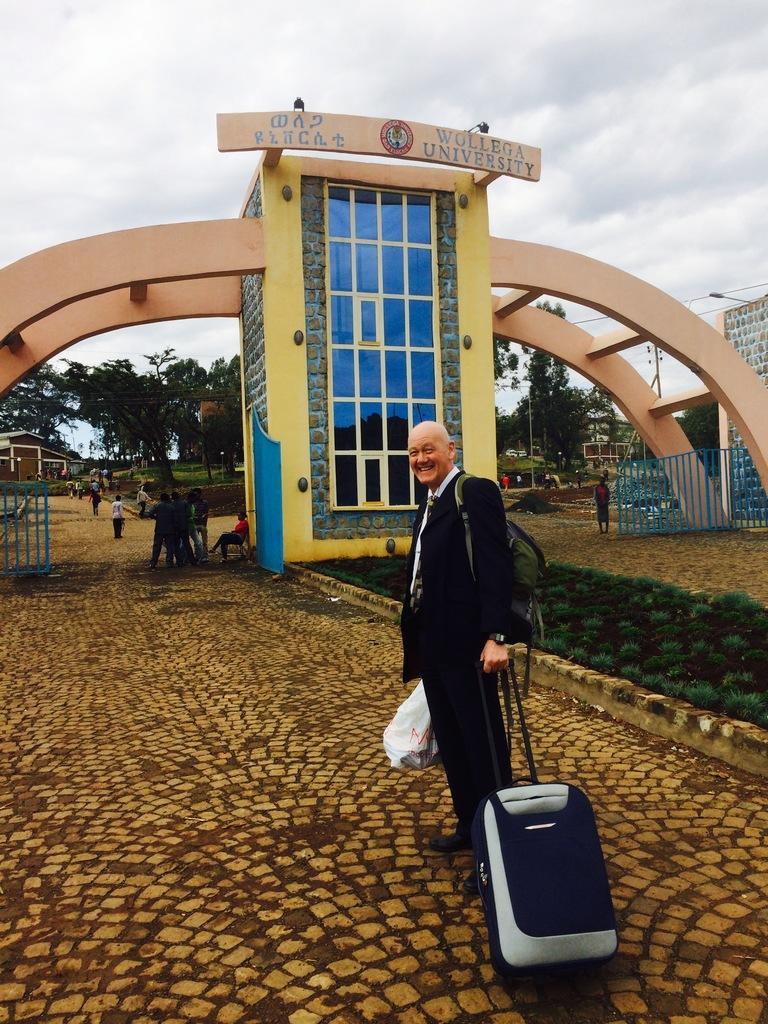Please provide a concise description of this image. In the center of the image there is a person standing with trolley on the ground. In the background we can see larch, trees, grass, persons, sky and clouds. 